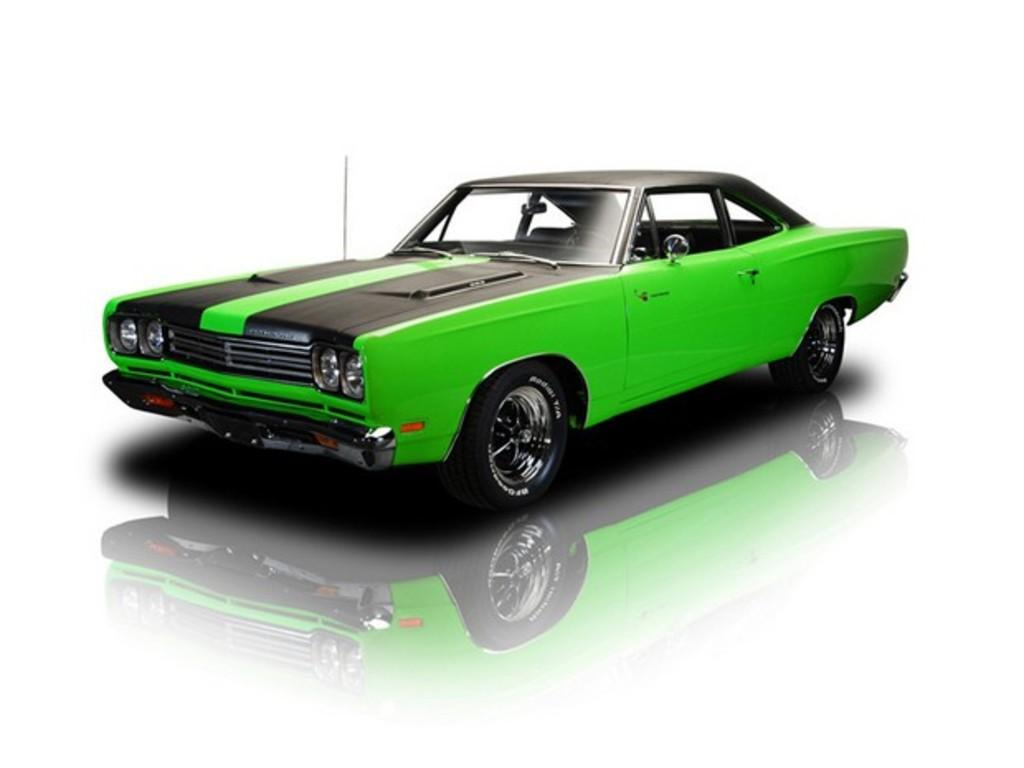What is the main subject of the image? The main subject of the image is a car. Can you describe the color combination of the car? The car has a black and green color combination. Where is the car located in the image? The car is placed on a surface. What can be seen at the bottom of the image? The car's reflection is visible at the bottom of the image. What type of owl can be seen sitting on the car's hood in the image? There is no owl present on the car's hood in the image. What sense is being used by the car to detect its surroundings in the image? Cars do not have senses like humans or animals; they use sensors and other technologies to detect their surroundings. 